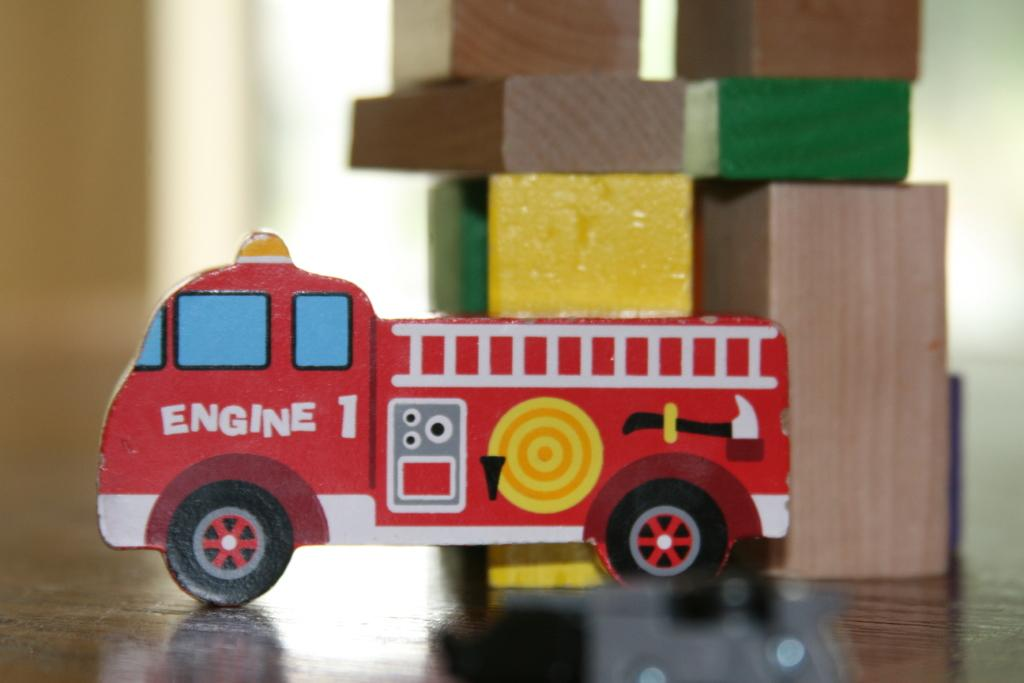What type of toy is in the image? There is a toy vehicle in the image. What colors can be seen on the toy vehicle? The toy vehicle is red, white, yellow, and black in color. What other objects are in the image besides the toy vehicle? There are wooden blocks in the image. How would you describe the background of the image? The background of the image is blurry. What type of bun is being served in the park in the image? There is no bun or park present in the image; it features a toy vehicle and wooden blocks. What kind of shoes are the children wearing while playing with the toy vehicle in the image? There are no children or shoes present in the image; it only shows a toy vehicle and wooden blocks. 